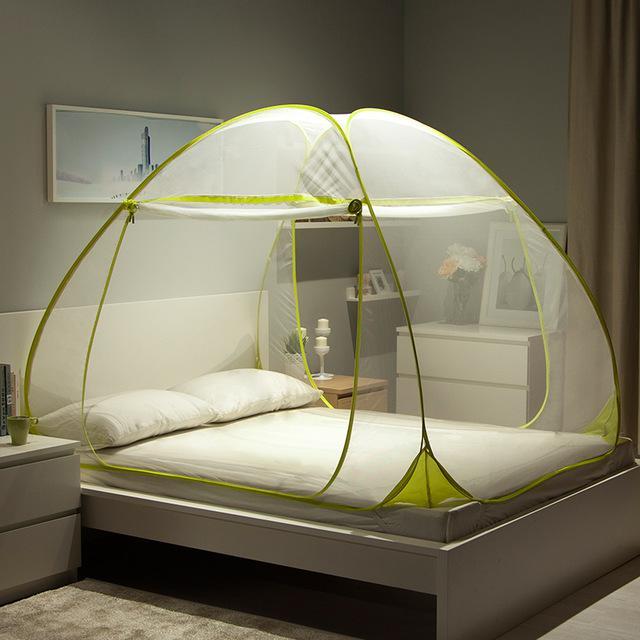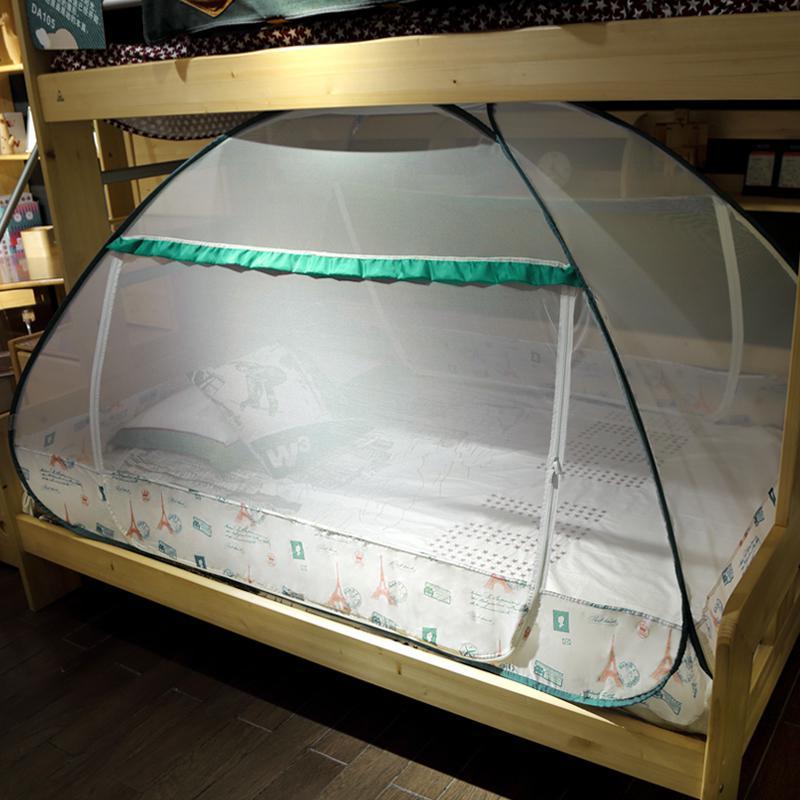The first image is the image on the left, the second image is the image on the right. Assess this claim about the two images: "A bed canopy has a checkered fabric strip around the bottom.". Correct or not? Answer yes or no. No. The first image is the image on the left, the second image is the image on the right. For the images displayed, is the sentence "There is artwork on the wall behind the bed in the right image." factually correct? Answer yes or no. No. 